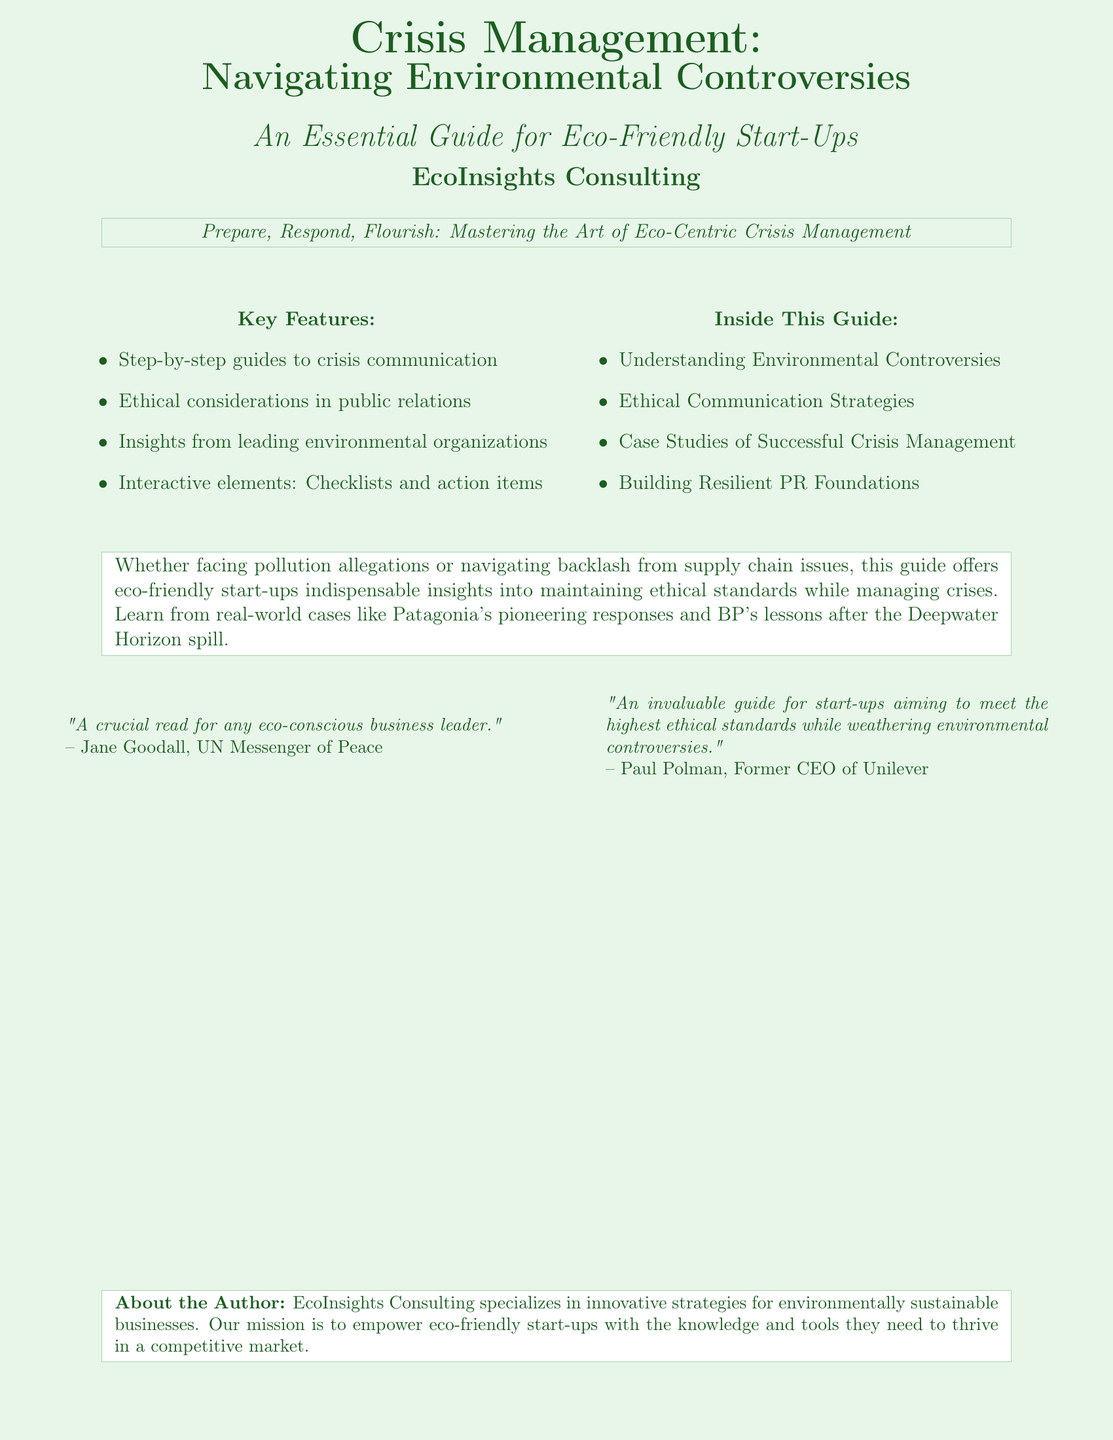What is the main title of the book? The main title of the book is prominently displayed in large fonts on the cover.
Answer: Crisis Management: Navigating Environmental Controversies Who is the author of this guide? The author or organization behind the guide is mentioned at the bottom of the cover.
Answer: EcoInsights Consulting What is one key feature of the guide? Key features are outlined in a bulleted list.
Answer: Step-by-step guides to crisis communication What does the book suggest about crisis management? The slogan on the cover indicates the main theme of the guide.
Answer: Prepare, Respond, Flourish Which quote is attributed to Jane Goodall? The quote from Jane Goodall is displayed in a specific section acknowledging endorsements.
Answer: A crucial read for any eco-conscious business leader What type of strategies does the book cover? The inside sections provide a focus on particular strategies related to the theme.
Answer: Ethical Communication Strategies Name one environmental controversy addressed in the case studies. The summary references real-world cases, implying various controversies are covered.
Answer: Patagonia's pioneering responses What is the primary audience of this guide? The audience is indicated through a descriptive phrase on the cover.
Answer: Eco-friendly start-ups 